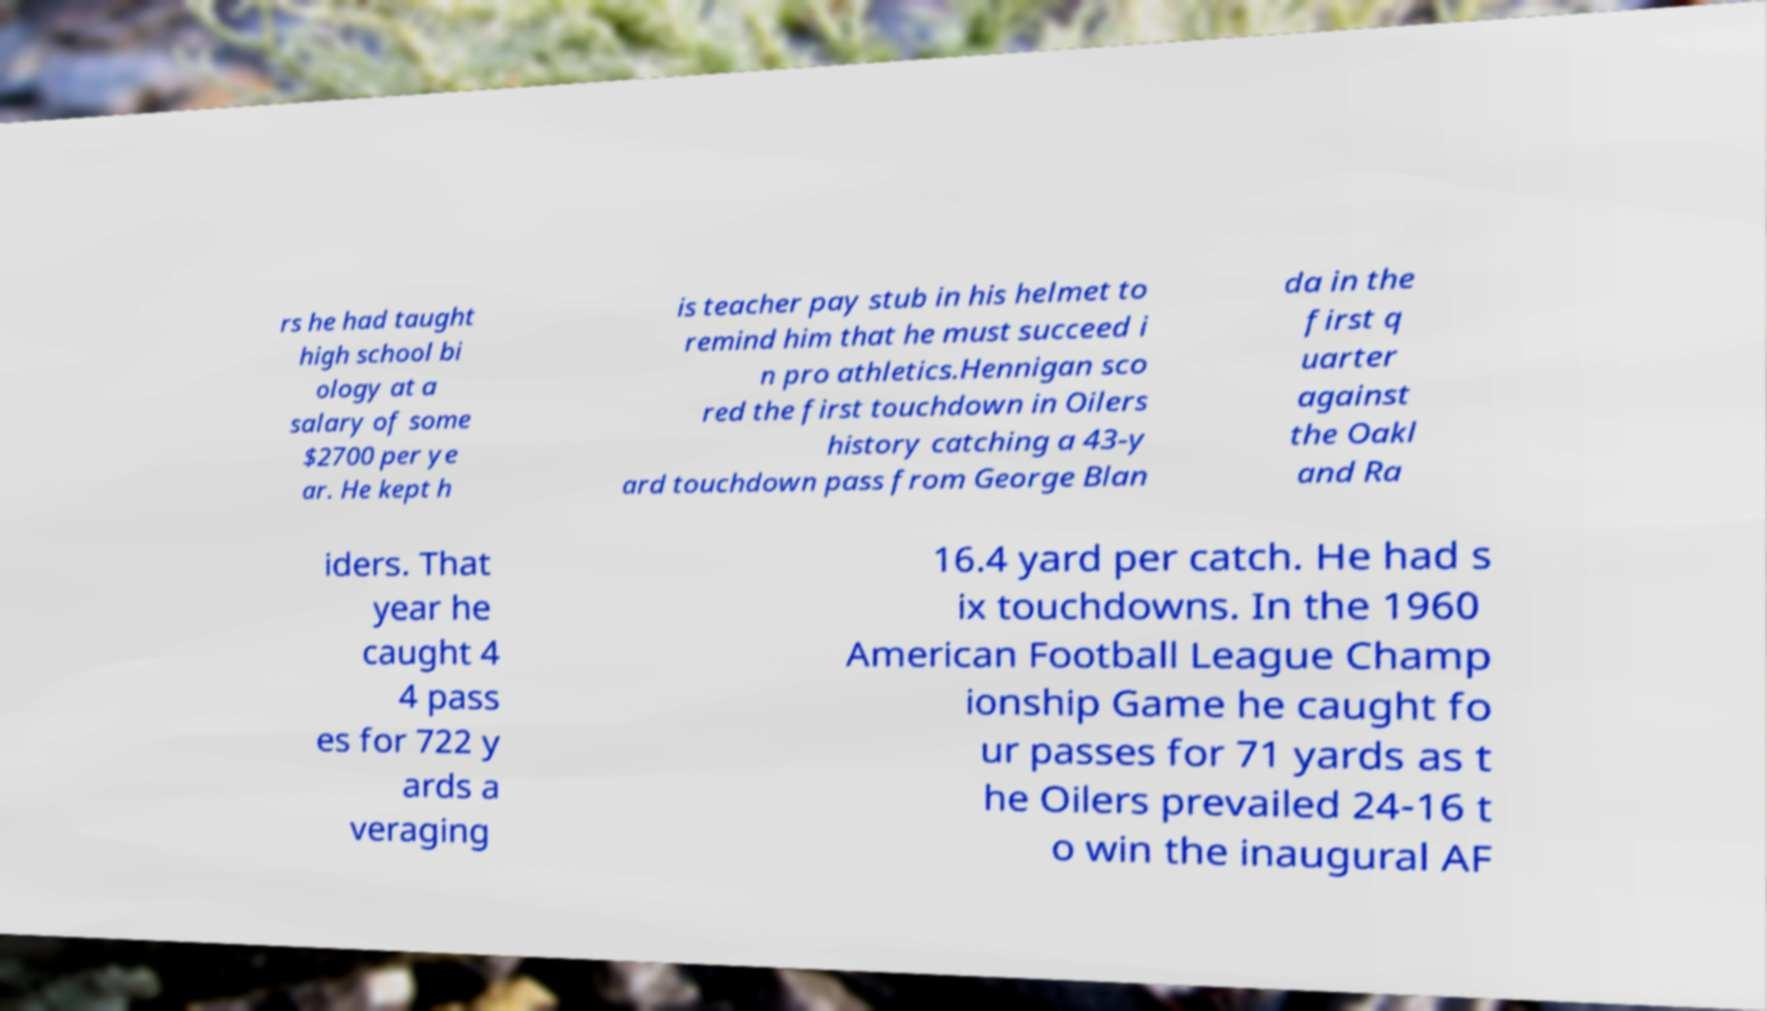Could you extract and type out the text from this image? rs he had taught high school bi ology at a salary of some $2700 per ye ar. He kept h is teacher pay stub in his helmet to remind him that he must succeed i n pro athletics.Hennigan sco red the first touchdown in Oilers history catching a 43-y ard touchdown pass from George Blan da in the first q uarter against the Oakl and Ra iders. That year he caught 4 4 pass es for 722 y ards a veraging 16.4 yard per catch. He had s ix touchdowns. In the 1960 American Football League Champ ionship Game he caught fo ur passes for 71 yards as t he Oilers prevailed 24-16 t o win the inaugural AF 